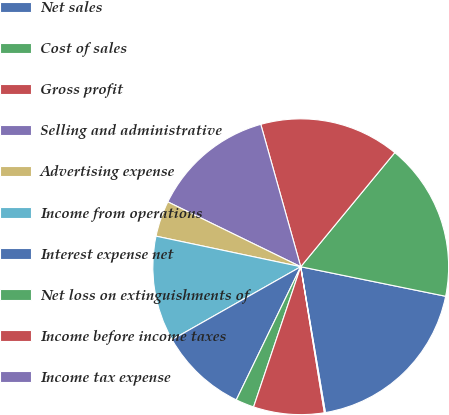<chart> <loc_0><loc_0><loc_500><loc_500><pie_chart><fcel>Net sales<fcel>Cost of sales<fcel>Gross profit<fcel>Selling and administrative<fcel>Advertising expense<fcel>Income from operations<fcel>Interest expense net<fcel>Net loss on extinguishments of<fcel>Income before income taxes<fcel>Income tax expense<nl><fcel>19.13%<fcel>17.23%<fcel>15.32%<fcel>13.42%<fcel>3.91%<fcel>11.52%<fcel>9.62%<fcel>2.01%<fcel>7.72%<fcel>0.11%<nl></chart> 